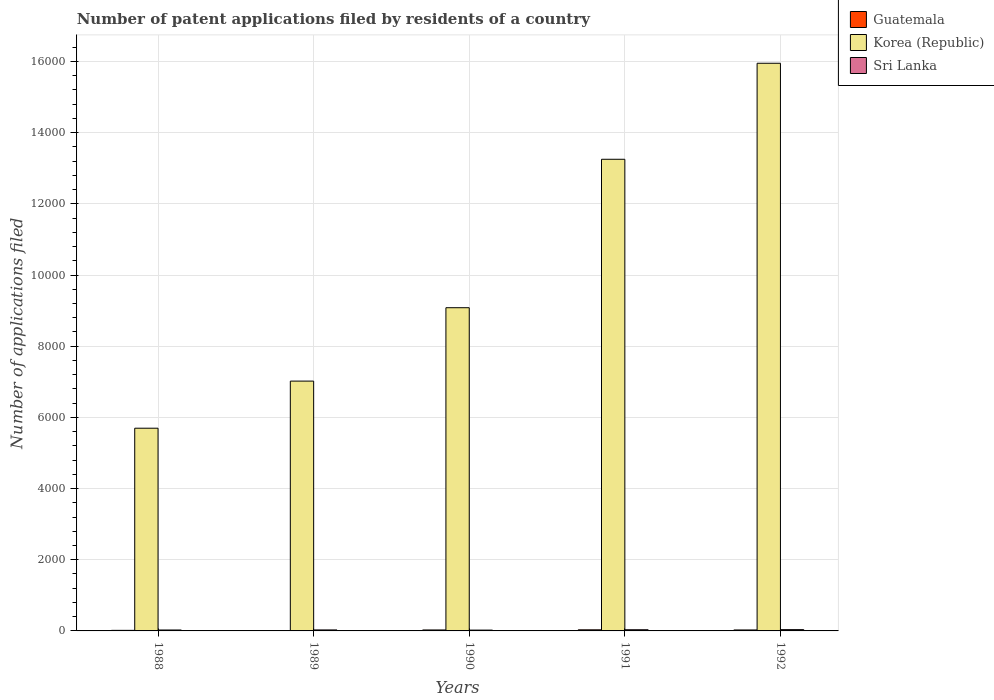How many different coloured bars are there?
Give a very brief answer. 3. Are the number of bars on each tick of the X-axis equal?
Provide a short and direct response. Yes. How many bars are there on the 4th tick from the left?
Give a very brief answer. 3. What is the label of the 4th group of bars from the left?
Provide a short and direct response. 1991. What is the number of applications filed in Korea (Republic) in 1992?
Offer a terse response. 1.60e+04. Across all years, what is the maximum number of applications filed in Sri Lanka?
Provide a succinct answer. 36. Across all years, what is the minimum number of applications filed in Guatemala?
Offer a terse response. 5. What is the total number of applications filed in Guatemala in the graph?
Make the answer very short. 106. What is the difference between the number of applications filed in Korea (Republic) in 1988 and that in 1992?
Provide a short and direct response. -1.03e+04. What is the difference between the number of applications filed in Sri Lanka in 1992 and the number of applications filed in Guatemala in 1990?
Offer a terse response. 9. What is the average number of applications filed in Guatemala per year?
Ensure brevity in your answer.  21.2. In the year 1989, what is the difference between the number of applications filed in Korea (Republic) and number of applications filed in Guatemala?
Offer a terse response. 7015. In how many years, is the number of applications filed in Sri Lanka greater than 3200?
Offer a very short reply. 0. What is the ratio of the number of applications filed in Sri Lanka in 1991 to that in 1992?
Give a very brief answer. 0.92. What is the difference between the highest and the second highest number of applications filed in Guatemala?
Give a very brief answer. 4. What does the 3rd bar from the left in 1989 represents?
Provide a short and direct response. Sri Lanka. What does the 3rd bar from the right in 1990 represents?
Offer a terse response. Guatemala. Are all the bars in the graph horizontal?
Your response must be concise. No. What is the difference between two consecutive major ticks on the Y-axis?
Provide a succinct answer. 2000. Are the values on the major ticks of Y-axis written in scientific E-notation?
Offer a very short reply. No. Does the graph contain any zero values?
Keep it short and to the point. No. Does the graph contain grids?
Ensure brevity in your answer.  Yes. How are the legend labels stacked?
Offer a terse response. Vertical. What is the title of the graph?
Keep it short and to the point. Number of patent applications filed by residents of a country. Does "Philippines" appear as one of the legend labels in the graph?
Give a very brief answer. No. What is the label or title of the Y-axis?
Keep it short and to the point. Number of applications filed. What is the Number of applications filed in Korea (Republic) in 1988?
Keep it short and to the point. 5696. What is the Number of applications filed in Sri Lanka in 1988?
Provide a succinct answer. 26. What is the Number of applications filed in Guatemala in 1989?
Make the answer very short. 5. What is the Number of applications filed of Korea (Republic) in 1989?
Your response must be concise. 7020. What is the Number of applications filed in Sri Lanka in 1989?
Your answer should be compact. 28. What is the Number of applications filed of Korea (Republic) in 1990?
Provide a succinct answer. 9082. What is the Number of applications filed of Guatemala in 1991?
Offer a terse response. 31. What is the Number of applications filed of Korea (Republic) in 1991?
Provide a succinct answer. 1.33e+04. What is the Number of applications filed of Sri Lanka in 1991?
Give a very brief answer. 33. What is the Number of applications filed in Korea (Republic) in 1992?
Keep it short and to the point. 1.60e+04. Across all years, what is the maximum Number of applications filed in Guatemala?
Give a very brief answer. 31. Across all years, what is the maximum Number of applications filed in Korea (Republic)?
Your response must be concise. 1.60e+04. Across all years, what is the minimum Number of applications filed in Korea (Republic)?
Keep it short and to the point. 5696. What is the total Number of applications filed of Guatemala in the graph?
Your answer should be compact. 106. What is the total Number of applications filed in Korea (Republic) in the graph?
Make the answer very short. 5.10e+04. What is the total Number of applications filed of Sri Lanka in the graph?
Your response must be concise. 146. What is the difference between the Number of applications filed of Korea (Republic) in 1988 and that in 1989?
Offer a very short reply. -1324. What is the difference between the Number of applications filed of Sri Lanka in 1988 and that in 1989?
Give a very brief answer. -2. What is the difference between the Number of applications filed in Korea (Republic) in 1988 and that in 1990?
Make the answer very short. -3386. What is the difference between the Number of applications filed of Korea (Republic) in 1988 and that in 1991?
Make the answer very short. -7557. What is the difference between the Number of applications filed of Sri Lanka in 1988 and that in 1991?
Offer a very short reply. -7. What is the difference between the Number of applications filed of Korea (Republic) in 1988 and that in 1992?
Your response must be concise. -1.03e+04. What is the difference between the Number of applications filed in Korea (Republic) in 1989 and that in 1990?
Give a very brief answer. -2062. What is the difference between the Number of applications filed of Sri Lanka in 1989 and that in 1990?
Make the answer very short. 5. What is the difference between the Number of applications filed in Korea (Republic) in 1989 and that in 1991?
Provide a short and direct response. -6233. What is the difference between the Number of applications filed in Korea (Republic) in 1989 and that in 1992?
Your answer should be very brief. -8931. What is the difference between the Number of applications filed of Sri Lanka in 1989 and that in 1992?
Offer a terse response. -8. What is the difference between the Number of applications filed of Korea (Republic) in 1990 and that in 1991?
Your response must be concise. -4171. What is the difference between the Number of applications filed in Sri Lanka in 1990 and that in 1991?
Provide a short and direct response. -10. What is the difference between the Number of applications filed of Korea (Republic) in 1990 and that in 1992?
Offer a terse response. -6869. What is the difference between the Number of applications filed of Sri Lanka in 1990 and that in 1992?
Keep it short and to the point. -13. What is the difference between the Number of applications filed in Korea (Republic) in 1991 and that in 1992?
Keep it short and to the point. -2698. What is the difference between the Number of applications filed of Sri Lanka in 1991 and that in 1992?
Your answer should be compact. -3. What is the difference between the Number of applications filed of Guatemala in 1988 and the Number of applications filed of Korea (Republic) in 1989?
Your response must be concise. -7004. What is the difference between the Number of applications filed of Guatemala in 1988 and the Number of applications filed of Sri Lanka in 1989?
Offer a terse response. -12. What is the difference between the Number of applications filed of Korea (Republic) in 1988 and the Number of applications filed of Sri Lanka in 1989?
Your answer should be very brief. 5668. What is the difference between the Number of applications filed in Guatemala in 1988 and the Number of applications filed in Korea (Republic) in 1990?
Ensure brevity in your answer.  -9066. What is the difference between the Number of applications filed in Guatemala in 1988 and the Number of applications filed in Sri Lanka in 1990?
Your answer should be very brief. -7. What is the difference between the Number of applications filed of Korea (Republic) in 1988 and the Number of applications filed of Sri Lanka in 1990?
Offer a very short reply. 5673. What is the difference between the Number of applications filed of Guatemala in 1988 and the Number of applications filed of Korea (Republic) in 1991?
Make the answer very short. -1.32e+04. What is the difference between the Number of applications filed in Korea (Republic) in 1988 and the Number of applications filed in Sri Lanka in 1991?
Your answer should be very brief. 5663. What is the difference between the Number of applications filed in Guatemala in 1988 and the Number of applications filed in Korea (Republic) in 1992?
Keep it short and to the point. -1.59e+04. What is the difference between the Number of applications filed in Korea (Republic) in 1988 and the Number of applications filed in Sri Lanka in 1992?
Provide a short and direct response. 5660. What is the difference between the Number of applications filed of Guatemala in 1989 and the Number of applications filed of Korea (Republic) in 1990?
Make the answer very short. -9077. What is the difference between the Number of applications filed in Korea (Republic) in 1989 and the Number of applications filed in Sri Lanka in 1990?
Provide a short and direct response. 6997. What is the difference between the Number of applications filed in Guatemala in 1989 and the Number of applications filed in Korea (Republic) in 1991?
Ensure brevity in your answer.  -1.32e+04. What is the difference between the Number of applications filed in Korea (Republic) in 1989 and the Number of applications filed in Sri Lanka in 1991?
Your answer should be compact. 6987. What is the difference between the Number of applications filed in Guatemala in 1989 and the Number of applications filed in Korea (Republic) in 1992?
Offer a very short reply. -1.59e+04. What is the difference between the Number of applications filed of Guatemala in 1989 and the Number of applications filed of Sri Lanka in 1992?
Your answer should be compact. -31. What is the difference between the Number of applications filed in Korea (Republic) in 1989 and the Number of applications filed in Sri Lanka in 1992?
Your answer should be compact. 6984. What is the difference between the Number of applications filed in Guatemala in 1990 and the Number of applications filed in Korea (Republic) in 1991?
Make the answer very short. -1.32e+04. What is the difference between the Number of applications filed of Korea (Republic) in 1990 and the Number of applications filed of Sri Lanka in 1991?
Give a very brief answer. 9049. What is the difference between the Number of applications filed of Guatemala in 1990 and the Number of applications filed of Korea (Republic) in 1992?
Give a very brief answer. -1.59e+04. What is the difference between the Number of applications filed in Korea (Republic) in 1990 and the Number of applications filed in Sri Lanka in 1992?
Your response must be concise. 9046. What is the difference between the Number of applications filed in Guatemala in 1991 and the Number of applications filed in Korea (Republic) in 1992?
Your answer should be compact. -1.59e+04. What is the difference between the Number of applications filed of Korea (Republic) in 1991 and the Number of applications filed of Sri Lanka in 1992?
Offer a very short reply. 1.32e+04. What is the average Number of applications filed in Guatemala per year?
Offer a very short reply. 21.2. What is the average Number of applications filed in Korea (Republic) per year?
Keep it short and to the point. 1.02e+04. What is the average Number of applications filed in Sri Lanka per year?
Offer a very short reply. 29.2. In the year 1988, what is the difference between the Number of applications filed of Guatemala and Number of applications filed of Korea (Republic)?
Keep it short and to the point. -5680. In the year 1988, what is the difference between the Number of applications filed in Korea (Republic) and Number of applications filed in Sri Lanka?
Provide a succinct answer. 5670. In the year 1989, what is the difference between the Number of applications filed of Guatemala and Number of applications filed of Korea (Republic)?
Your answer should be compact. -7015. In the year 1989, what is the difference between the Number of applications filed in Guatemala and Number of applications filed in Sri Lanka?
Provide a short and direct response. -23. In the year 1989, what is the difference between the Number of applications filed in Korea (Republic) and Number of applications filed in Sri Lanka?
Offer a terse response. 6992. In the year 1990, what is the difference between the Number of applications filed of Guatemala and Number of applications filed of Korea (Republic)?
Offer a terse response. -9055. In the year 1990, what is the difference between the Number of applications filed in Korea (Republic) and Number of applications filed in Sri Lanka?
Ensure brevity in your answer.  9059. In the year 1991, what is the difference between the Number of applications filed in Guatemala and Number of applications filed in Korea (Republic)?
Provide a short and direct response. -1.32e+04. In the year 1991, what is the difference between the Number of applications filed of Guatemala and Number of applications filed of Sri Lanka?
Provide a succinct answer. -2. In the year 1991, what is the difference between the Number of applications filed of Korea (Republic) and Number of applications filed of Sri Lanka?
Offer a terse response. 1.32e+04. In the year 1992, what is the difference between the Number of applications filed of Guatemala and Number of applications filed of Korea (Republic)?
Your response must be concise. -1.59e+04. In the year 1992, what is the difference between the Number of applications filed of Korea (Republic) and Number of applications filed of Sri Lanka?
Provide a succinct answer. 1.59e+04. What is the ratio of the Number of applications filed in Guatemala in 1988 to that in 1989?
Offer a terse response. 3.2. What is the ratio of the Number of applications filed of Korea (Republic) in 1988 to that in 1989?
Your response must be concise. 0.81. What is the ratio of the Number of applications filed of Sri Lanka in 1988 to that in 1989?
Your answer should be compact. 0.93. What is the ratio of the Number of applications filed of Guatemala in 1988 to that in 1990?
Make the answer very short. 0.59. What is the ratio of the Number of applications filed in Korea (Republic) in 1988 to that in 1990?
Your answer should be compact. 0.63. What is the ratio of the Number of applications filed of Sri Lanka in 1988 to that in 1990?
Offer a very short reply. 1.13. What is the ratio of the Number of applications filed of Guatemala in 1988 to that in 1991?
Ensure brevity in your answer.  0.52. What is the ratio of the Number of applications filed of Korea (Republic) in 1988 to that in 1991?
Offer a terse response. 0.43. What is the ratio of the Number of applications filed in Sri Lanka in 1988 to that in 1991?
Your response must be concise. 0.79. What is the ratio of the Number of applications filed of Guatemala in 1988 to that in 1992?
Offer a terse response. 0.59. What is the ratio of the Number of applications filed in Korea (Republic) in 1988 to that in 1992?
Give a very brief answer. 0.36. What is the ratio of the Number of applications filed in Sri Lanka in 1988 to that in 1992?
Keep it short and to the point. 0.72. What is the ratio of the Number of applications filed in Guatemala in 1989 to that in 1990?
Offer a very short reply. 0.19. What is the ratio of the Number of applications filed of Korea (Republic) in 1989 to that in 1990?
Provide a succinct answer. 0.77. What is the ratio of the Number of applications filed in Sri Lanka in 1989 to that in 1990?
Provide a short and direct response. 1.22. What is the ratio of the Number of applications filed in Guatemala in 1989 to that in 1991?
Offer a very short reply. 0.16. What is the ratio of the Number of applications filed of Korea (Republic) in 1989 to that in 1991?
Offer a terse response. 0.53. What is the ratio of the Number of applications filed in Sri Lanka in 1989 to that in 1991?
Give a very brief answer. 0.85. What is the ratio of the Number of applications filed of Guatemala in 1989 to that in 1992?
Your answer should be compact. 0.19. What is the ratio of the Number of applications filed in Korea (Republic) in 1989 to that in 1992?
Make the answer very short. 0.44. What is the ratio of the Number of applications filed in Guatemala in 1990 to that in 1991?
Make the answer very short. 0.87. What is the ratio of the Number of applications filed of Korea (Republic) in 1990 to that in 1991?
Your answer should be compact. 0.69. What is the ratio of the Number of applications filed in Sri Lanka in 1990 to that in 1991?
Offer a terse response. 0.7. What is the ratio of the Number of applications filed in Korea (Republic) in 1990 to that in 1992?
Keep it short and to the point. 0.57. What is the ratio of the Number of applications filed of Sri Lanka in 1990 to that in 1992?
Provide a succinct answer. 0.64. What is the ratio of the Number of applications filed of Guatemala in 1991 to that in 1992?
Your response must be concise. 1.15. What is the ratio of the Number of applications filed in Korea (Republic) in 1991 to that in 1992?
Your response must be concise. 0.83. What is the ratio of the Number of applications filed in Sri Lanka in 1991 to that in 1992?
Offer a terse response. 0.92. What is the difference between the highest and the second highest Number of applications filed in Korea (Republic)?
Ensure brevity in your answer.  2698. What is the difference between the highest and the second highest Number of applications filed of Sri Lanka?
Provide a short and direct response. 3. What is the difference between the highest and the lowest Number of applications filed in Guatemala?
Ensure brevity in your answer.  26. What is the difference between the highest and the lowest Number of applications filed of Korea (Republic)?
Give a very brief answer. 1.03e+04. What is the difference between the highest and the lowest Number of applications filed of Sri Lanka?
Keep it short and to the point. 13. 